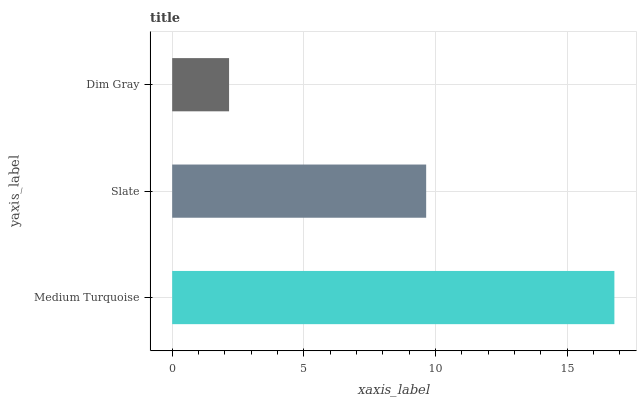Is Dim Gray the minimum?
Answer yes or no. Yes. Is Medium Turquoise the maximum?
Answer yes or no. Yes. Is Slate the minimum?
Answer yes or no. No. Is Slate the maximum?
Answer yes or no. No. Is Medium Turquoise greater than Slate?
Answer yes or no. Yes. Is Slate less than Medium Turquoise?
Answer yes or no. Yes. Is Slate greater than Medium Turquoise?
Answer yes or no. No. Is Medium Turquoise less than Slate?
Answer yes or no. No. Is Slate the high median?
Answer yes or no. Yes. Is Slate the low median?
Answer yes or no. Yes. Is Medium Turquoise the high median?
Answer yes or no. No. Is Dim Gray the low median?
Answer yes or no. No. 